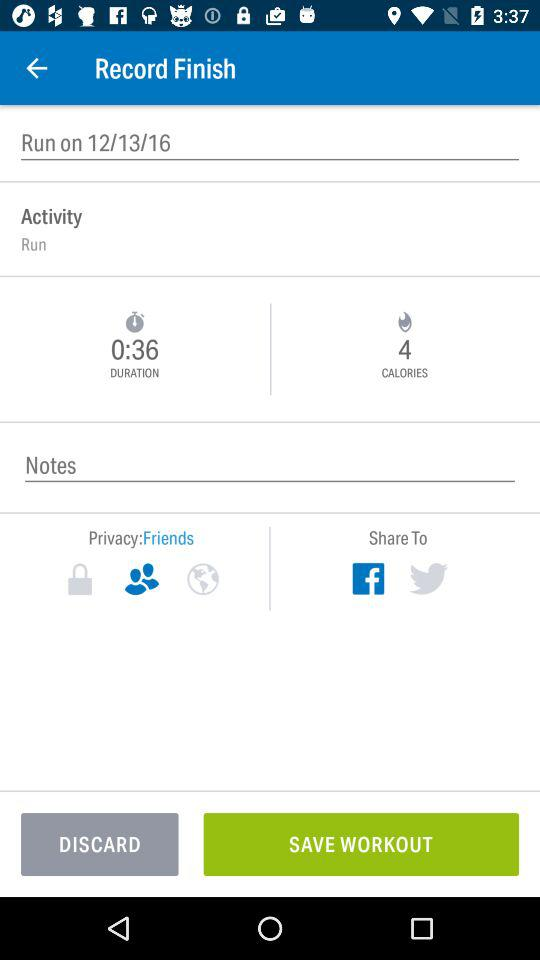What is the date of "Run on"? The date is December 13, 2016. 